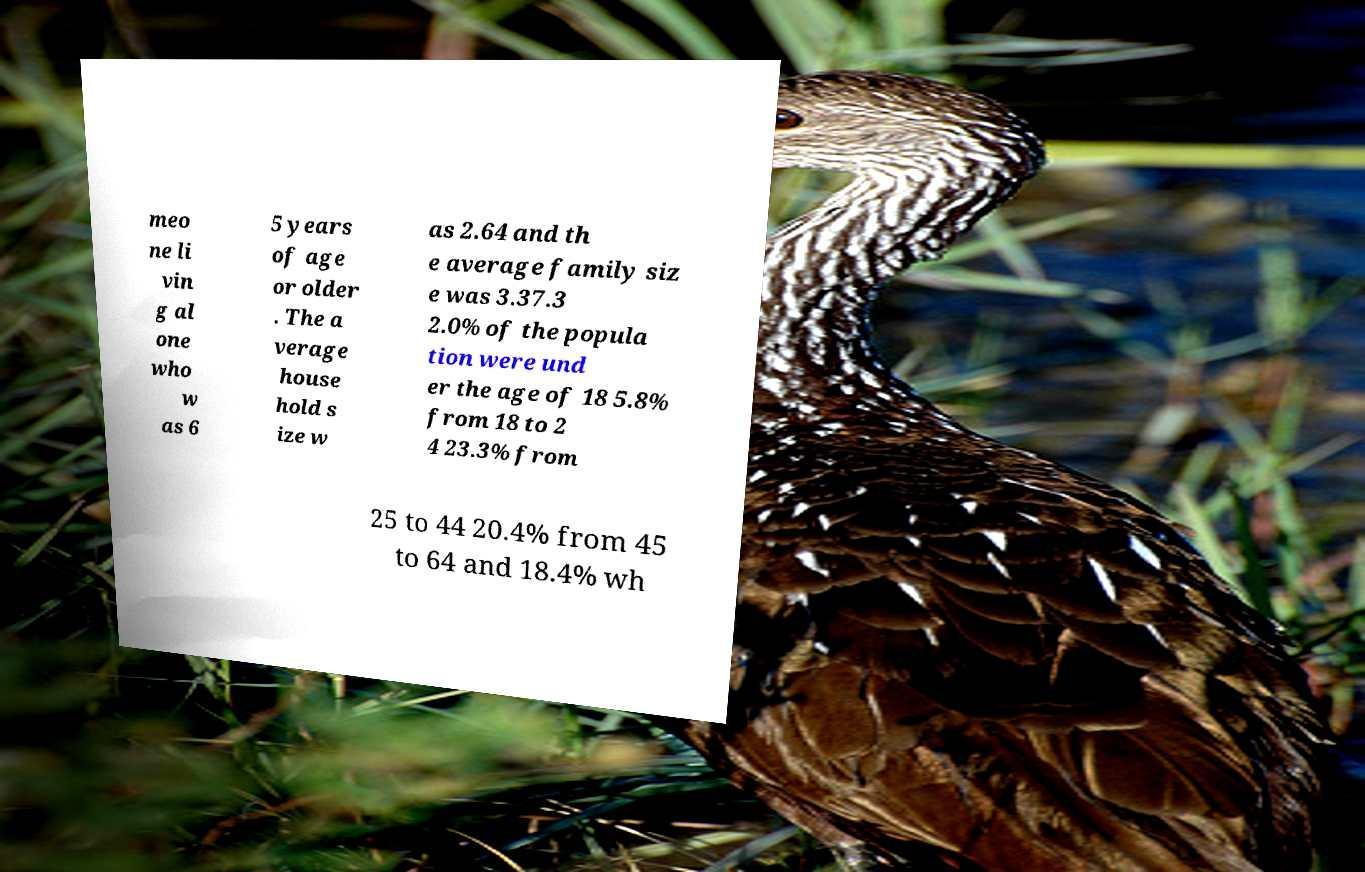Can you read and provide the text displayed in the image?This photo seems to have some interesting text. Can you extract and type it out for me? meo ne li vin g al one who w as 6 5 years of age or older . The a verage house hold s ize w as 2.64 and th e average family siz e was 3.37.3 2.0% of the popula tion were und er the age of 18 5.8% from 18 to 2 4 23.3% from 25 to 44 20.4% from 45 to 64 and 18.4% wh 